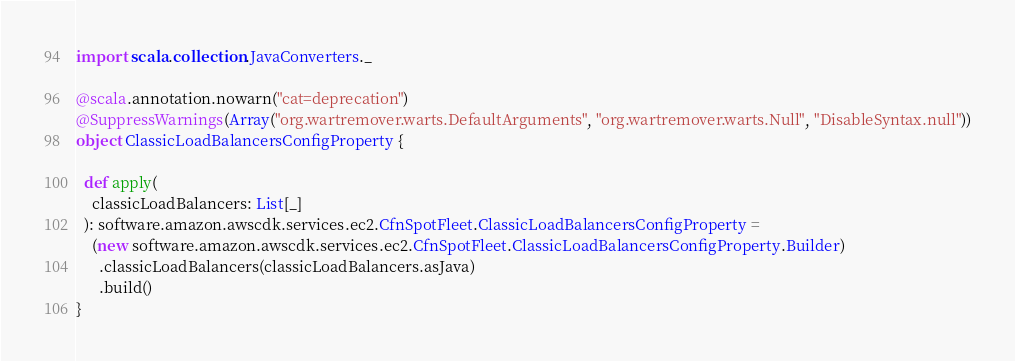Convert code to text. <code><loc_0><loc_0><loc_500><loc_500><_Scala_>import scala.collection.JavaConverters._

@scala.annotation.nowarn("cat=deprecation")
@SuppressWarnings(Array("org.wartremover.warts.DefaultArguments", "org.wartremover.warts.Null", "DisableSyntax.null"))
object ClassicLoadBalancersConfigProperty {

  def apply(
    classicLoadBalancers: List[_]
  ): software.amazon.awscdk.services.ec2.CfnSpotFleet.ClassicLoadBalancersConfigProperty =
    (new software.amazon.awscdk.services.ec2.CfnSpotFleet.ClassicLoadBalancersConfigProperty.Builder)
      .classicLoadBalancers(classicLoadBalancers.asJava)
      .build()
}
</code> 